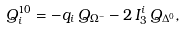Convert formula to latex. <formula><loc_0><loc_0><loc_500><loc_500>Q ^ { 1 0 } _ { i } = - q _ { i } \, Q _ { \Omega ^ { - } } - 2 \, I ^ { i } _ { 3 } \, Q _ { \Delta ^ { 0 } } ,</formula> 